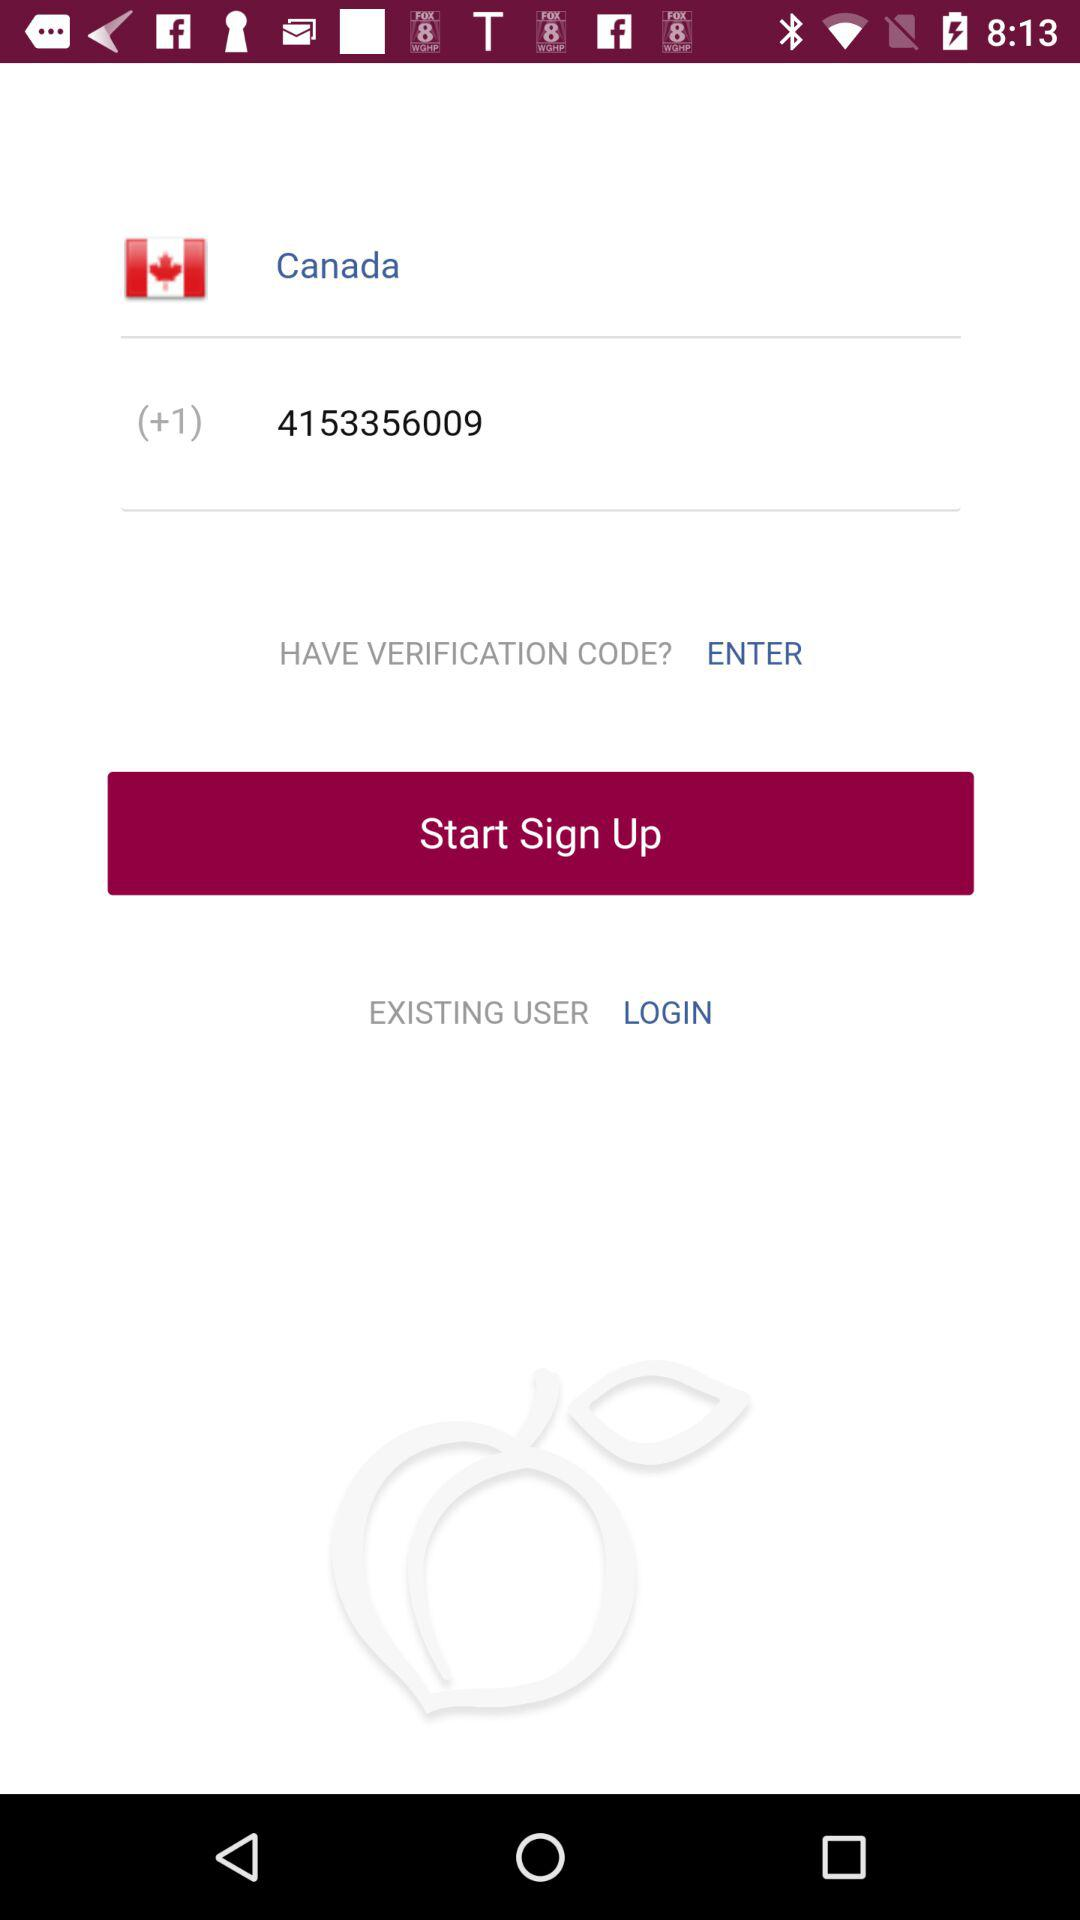What is the country name? The country name is Canada. 